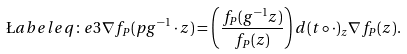<formula> <loc_0><loc_0><loc_500><loc_500>\L a b e l { e q \colon e 3 } \nabla f _ { P } ( p g ^ { - 1 } \cdot z ) = \left ( \frac { f _ { P } ( g ^ { - 1 } z ) } { f _ { P } ( z ) } \right ) d ( t \circ \cdot ) _ { z } \nabla f _ { P } ( z ) .</formula> 